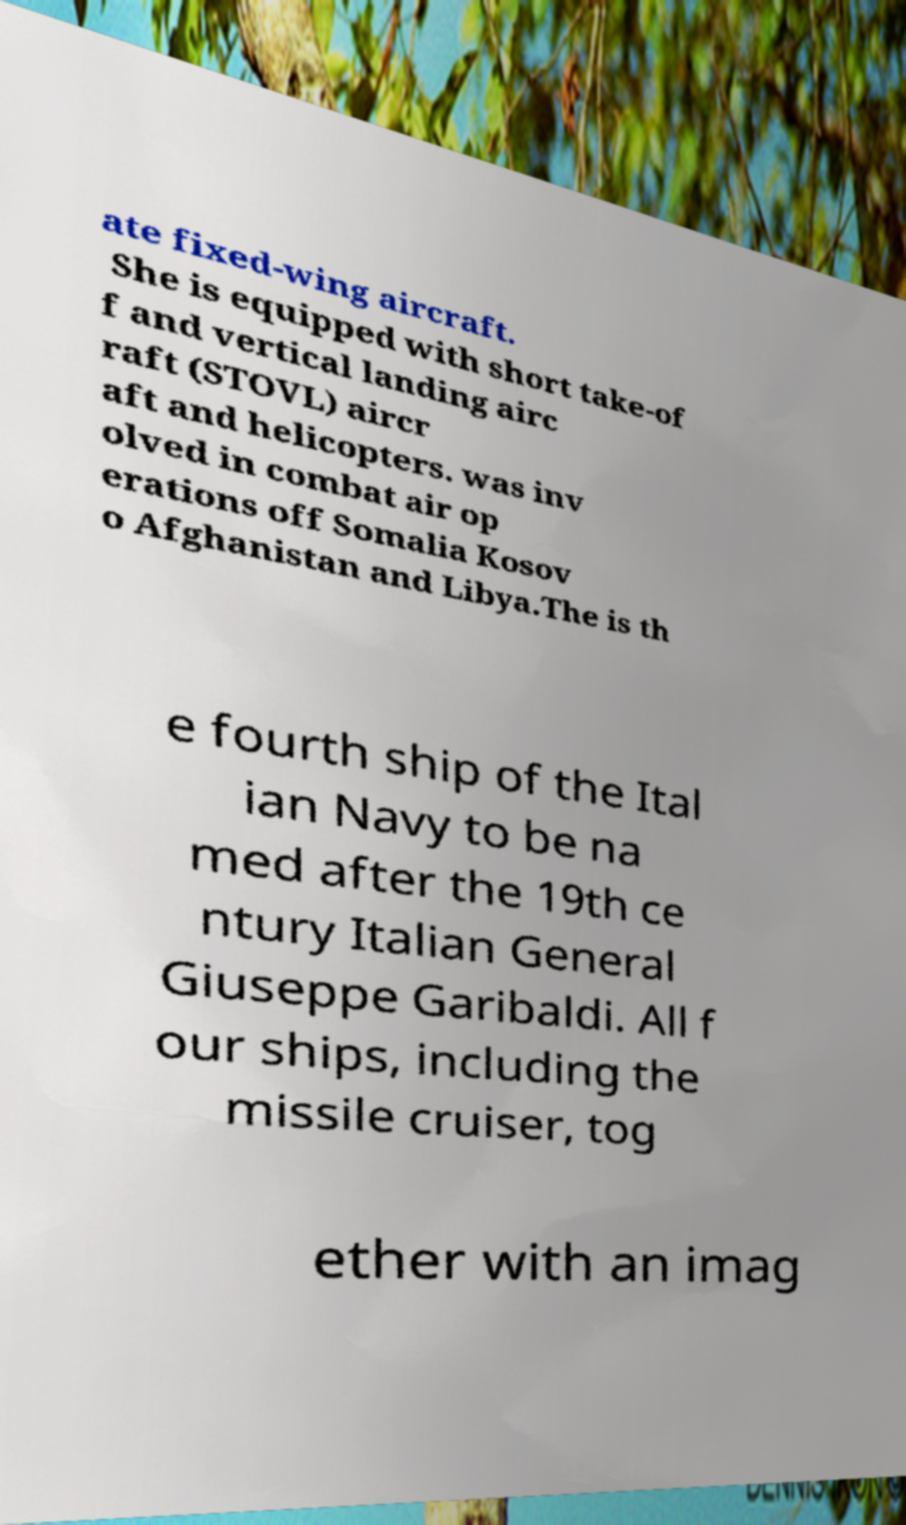What messages or text are displayed in this image? I need them in a readable, typed format. ate fixed-wing aircraft. She is equipped with short take-of f and vertical landing airc raft (STOVL) aircr aft and helicopters. was inv olved in combat air op erations off Somalia Kosov o Afghanistan and Libya.The is th e fourth ship of the Ital ian Navy to be na med after the 19th ce ntury Italian General Giuseppe Garibaldi. All f our ships, including the missile cruiser, tog ether with an imag 